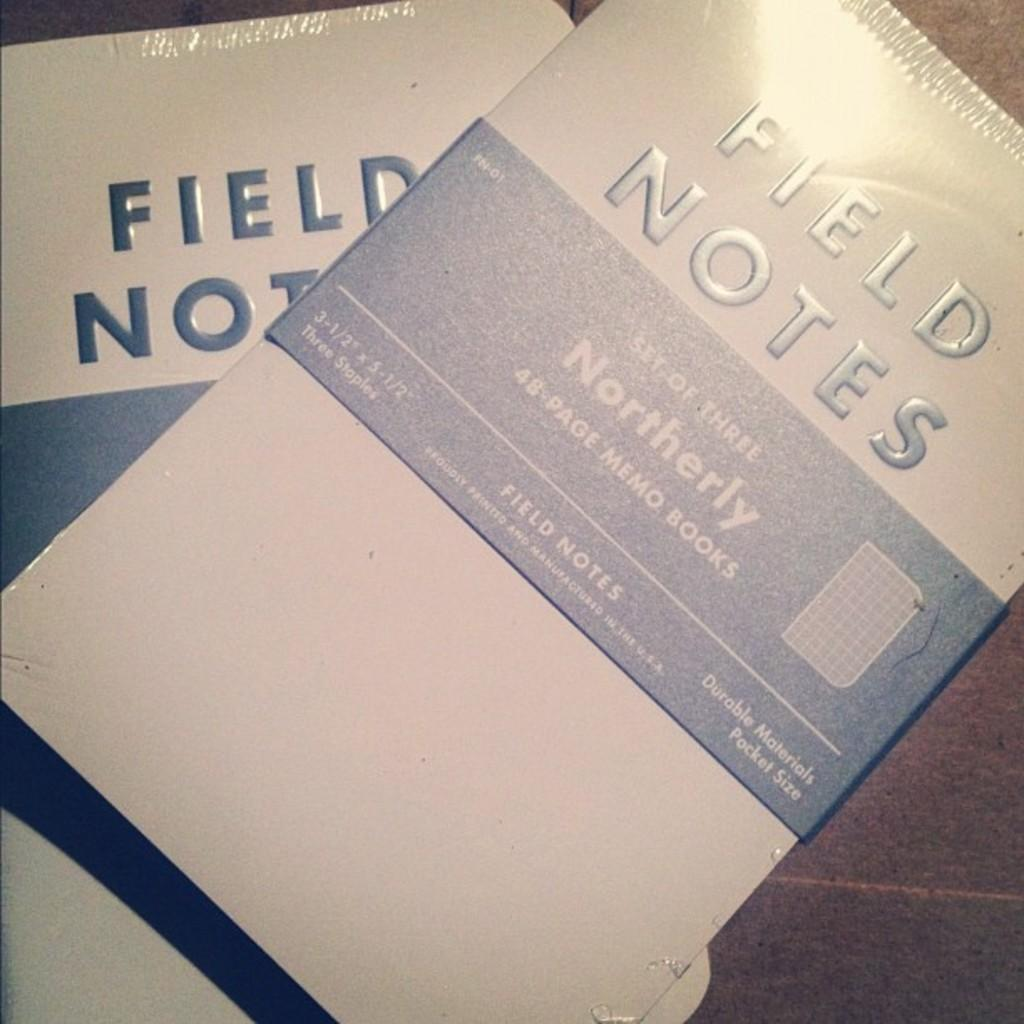<image>
Describe the image concisely. Two sets of three Field Notes memo books. 